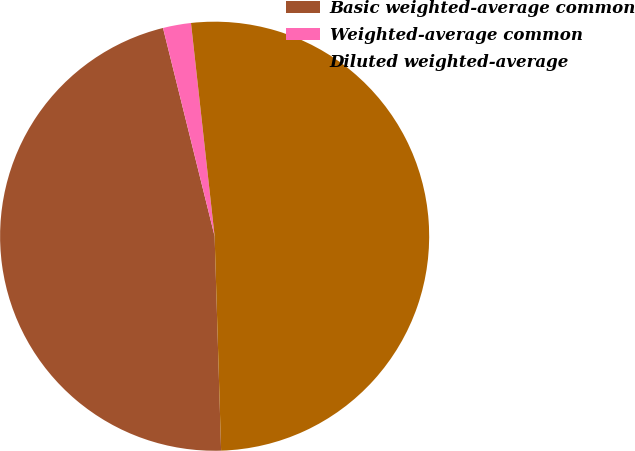Convert chart to OTSL. <chart><loc_0><loc_0><loc_500><loc_500><pie_chart><fcel>Basic weighted-average common<fcel>Weighted-average common<fcel>Diluted weighted-average<nl><fcel>46.61%<fcel>2.11%<fcel>51.27%<nl></chart> 